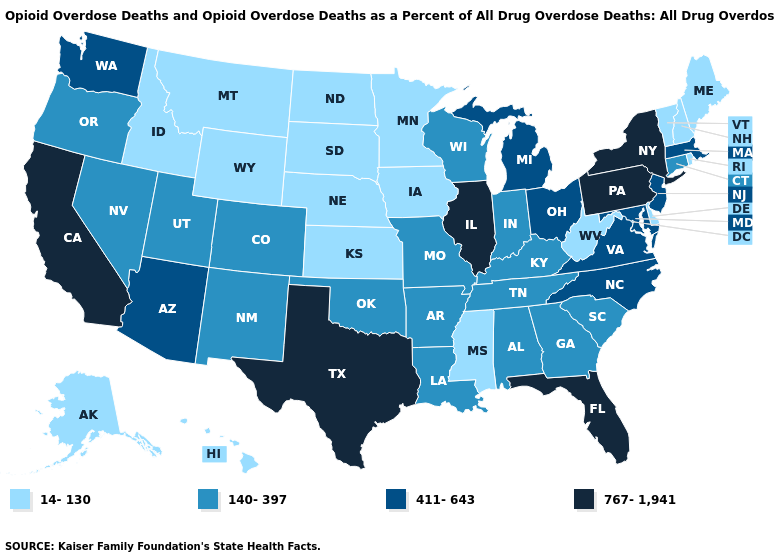Does Michigan have the highest value in the USA?
Answer briefly. No. Which states have the lowest value in the Northeast?
Short answer required. Maine, New Hampshire, Rhode Island, Vermont. What is the highest value in the South ?
Write a very short answer. 767-1,941. Name the states that have a value in the range 140-397?
Give a very brief answer. Alabama, Arkansas, Colorado, Connecticut, Georgia, Indiana, Kentucky, Louisiana, Missouri, Nevada, New Mexico, Oklahoma, Oregon, South Carolina, Tennessee, Utah, Wisconsin. Does Nebraska have a lower value than Louisiana?
Give a very brief answer. Yes. Does the first symbol in the legend represent the smallest category?
Quick response, please. Yes. What is the value of Iowa?
Short answer required. 14-130. Among the states that border Massachusetts , which have the lowest value?
Short answer required. New Hampshire, Rhode Island, Vermont. Which states have the highest value in the USA?
Quick response, please. California, Florida, Illinois, New York, Pennsylvania, Texas. Name the states that have a value in the range 767-1,941?
Write a very short answer. California, Florida, Illinois, New York, Pennsylvania, Texas. Which states have the lowest value in the USA?
Be succinct. Alaska, Delaware, Hawaii, Idaho, Iowa, Kansas, Maine, Minnesota, Mississippi, Montana, Nebraska, New Hampshire, North Dakota, Rhode Island, South Dakota, Vermont, West Virginia, Wyoming. What is the highest value in states that border Florida?
Be succinct. 140-397. Name the states that have a value in the range 767-1,941?
Give a very brief answer. California, Florida, Illinois, New York, Pennsylvania, Texas. Name the states that have a value in the range 411-643?
Be succinct. Arizona, Maryland, Massachusetts, Michigan, New Jersey, North Carolina, Ohio, Virginia, Washington. What is the highest value in the USA?
Give a very brief answer. 767-1,941. 